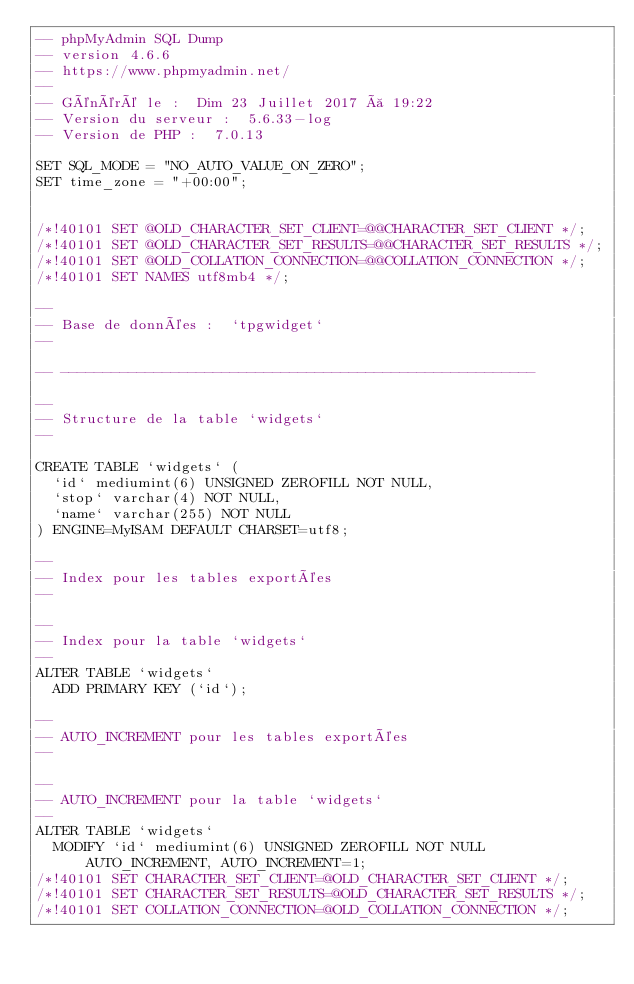<code> <loc_0><loc_0><loc_500><loc_500><_SQL_>-- phpMyAdmin SQL Dump
-- version 4.6.6
-- https://www.phpmyadmin.net/
--
-- Généré le :  Dim 23 Juillet 2017 à 19:22
-- Version du serveur :  5.6.33-log
-- Version de PHP :  7.0.13

SET SQL_MODE = "NO_AUTO_VALUE_ON_ZERO";
SET time_zone = "+00:00";


/*!40101 SET @OLD_CHARACTER_SET_CLIENT=@@CHARACTER_SET_CLIENT */;
/*!40101 SET @OLD_CHARACTER_SET_RESULTS=@@CHARACTER_SET_RESULTS */;
/*!40101 SET @OLD_COLLATION_CONNECTION=@@COLLATION_CONNECTION */;
/*!40101 SET NAMES utf8mb4 */;

--
-- Base de données :  `tpgwidget`
--

-- --------------------------------------------------------

--
-- Structure de la table `widgets`
--

CREATE TABLE `widgets` (
  `id` mediumint(6) UNSIGNED ZEROFILL NOT NULL,
  `stop` varchar(4) NOT NULL,
  `name` varchar(255) NOT NULL
) ENGINE=MyISAM DEFAULT CHARSET=utf8;

--
-- Index pour les tables exportées
--

--
-- Index pour la table `widgets`
--
ALTER TABLE `widgets`
  ADD PRIMARY KEY (`id`);

--
-- AUTO_INCREMENT pour les tables exportées
--

--
-- AUTO_INCREMENT pour la table `widgets`
--
ALTER TABLE `widgets`
  MODIFY `id` mediumint(6) UNSIGNED ZEROFILL NOT NULL AUTO_INCREMENT, AUTO_INCREMENT=1;
/*!40101 SET CHARACTER_SET_CLIENT=@OLD_CHARACTER_SET_CLIENT */;
/*!40101 SET CHARACTER_SET_RESULTS=@OLD_CHARACTER_SET_RESULTS */;
/*!40101 SET COLLATION_CONNECTION=@OLD_COLLATION_CONNECTION */;
</code> 